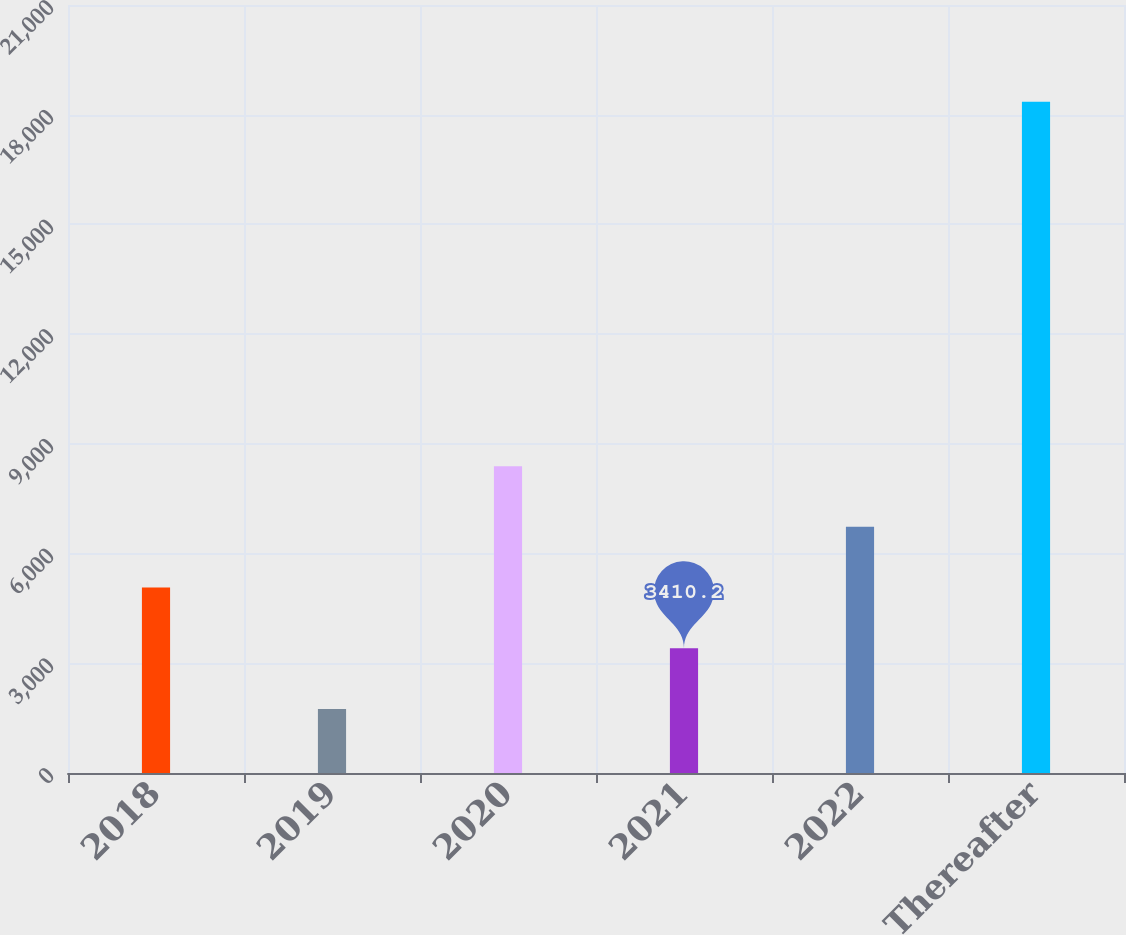Convert chart. <chart><loc_0><loc_0><loc_500><loc_500><bar_chart><fcel>2018<fcel>2019<fcel>2020<fcel>2021<fcel>2022<fcel>Thereafter<nl><fcel>5070.4<fcel>1750<fcel>8390.8<fcel>3410.2<fcel>6730.6<fcel>18352<nl></chart> 